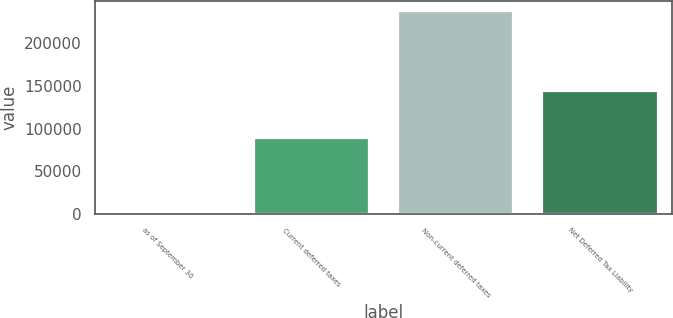<chart> <loc_0><loc_0><loc_500><loc_500><bar_chart><fcel>as of September 30<fcel>Current deferred taxes<fcel>Non-current deferred taxes<fcel>Net Deferred Tax Liability<nl><fcel>2010<fcel>89242<fcel>237810<fcel>143659<nl></chart> 